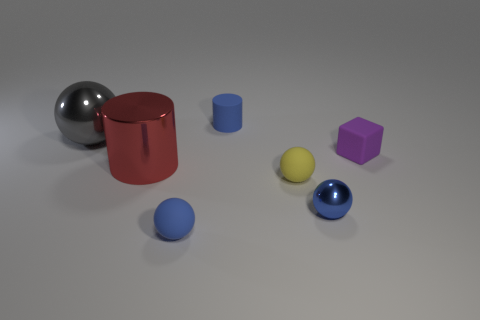Subtract all blue matte balls. How many balls are left? 3 Subtract all blue spheres. How many spheres are left? 2 Subtract 1 spheres. How many spheres are left? 3 Subtract all red cubes. Subtract all purple cylinders. How many cubes are left? 1 Subtract all cyan blocks. How many blue spheres are left? 2 Subtract all blue cylinders. Subtract all big red cylinders. How many objects are left? 5 Add 2 blue matte objects. How many blue matte objects are left? 4 Add 4 big cubes. How many big cubes exist? 4 Add 2 cyan objects. How many objects exist? 9 Subtract 0 brown balls. How many objects are left? 7 